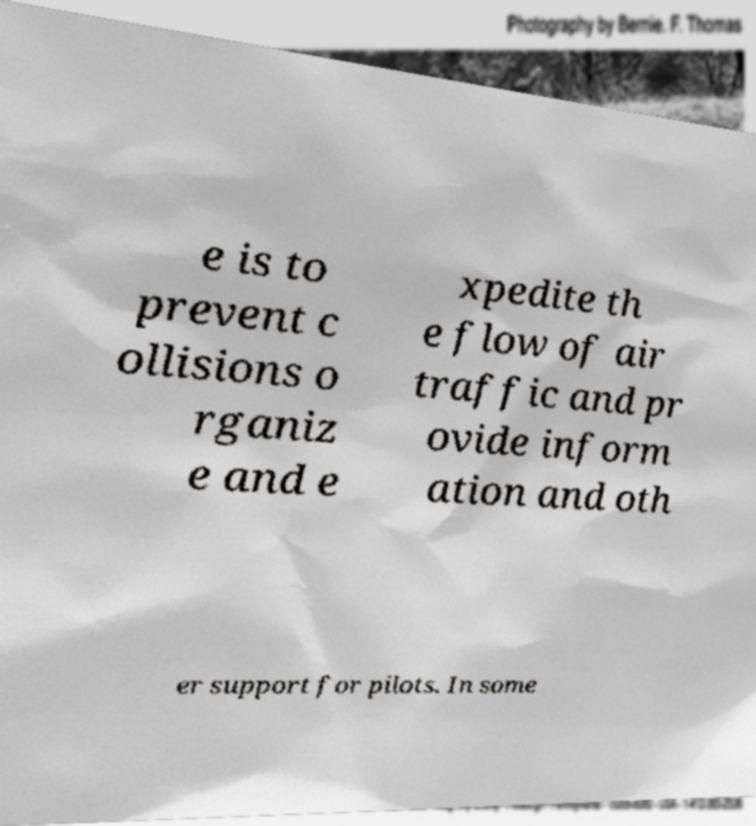What messages or text are displayed in this image? I need them in a readable, typed format. e is to prevent c ollisions o rganiz e and e xpedite th e flow of air traffic and pr ovide inform ation and oth er support for pilots. In some 